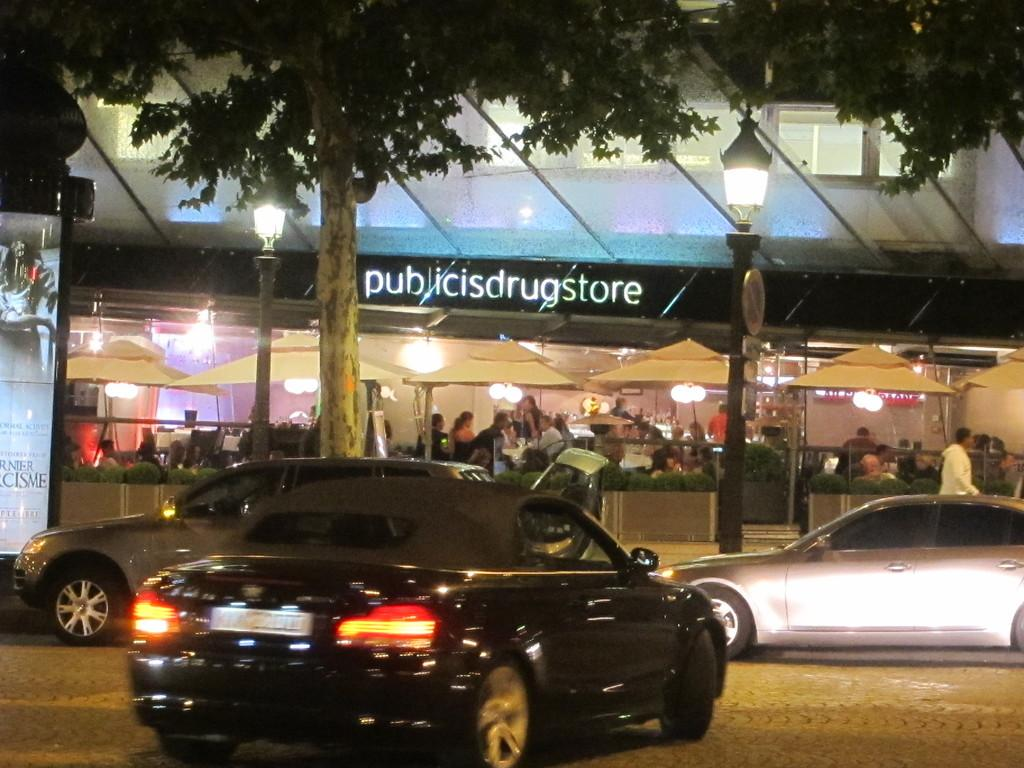What type of natural elements can be seen in the image? There are trees in the image. What type of man-made objects can be seen in the image? There are cars, a board, lights on poles, and a building in the image. What can be seen in the background of the image? There is a building, a plant, lights, and people in the background of the image. Can you tell me how many family members are visible in the image? There is no mention of a family or family members in the image. What type of edge can be seen on the board in the image? There is no specific edge mentioned or visible on the board in the image. 